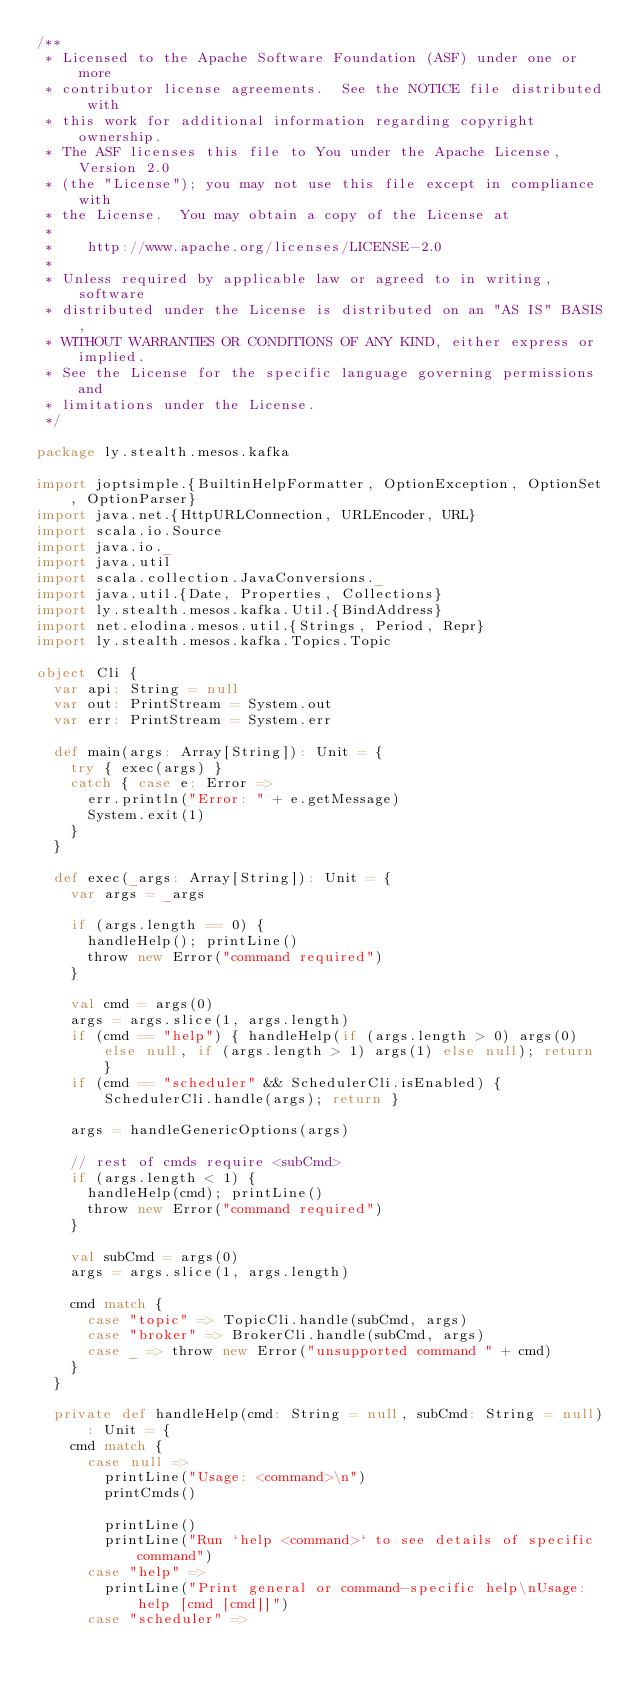<code> <loc_0><loc_0><loc_500><loc_500><_Scala_>/**
 * Licensed to the Apache Software Foundation (ASF) under one or more
 * contributor license agreements.  See the NOTICE file distributed with
 * this work for additional information regarding copyright ownership.
 * The ASF licenses this file to You under the Apache License, Version 2.0
 * (the "License"); you may not use this file except in compliance with
 * the License.  You may obtain a copy of the License at
 *
 *    http://www.apache.org/licenses/LICENSE-2.0
 *
 * Unless required by applicable law or agreed to in writing, software
 * distributed under the License is distributed on an "AS IS" BASIS,
 * WITHOUT WARRANTIES OR CONDITIONS OF ANY KIND, either express or implied.
 * See the License for the specific language governing permissions and
 * limitations under the License.
 */

package ly.stealth.mesos.kafka

import joptsimple.{BuiltinHelpFormatter, OptionException, OptionSet, OptionParser}
import java.net.{HttpURLConnection, URLEncoder, URL}
import scala.io.Source
import java.io._
import java.util
import scala.collection.JavaConversions._
import java.util.{Date, Properties, Collections}
import ly.stealth.mesos.kafka.Util.{BindAddress}
import net.elodina.mesos.util.{Strings, Period, Repr}
import ly.stealth.mesos.kafka.Topics.Topic

object Cli {
  var api: String = null
  var out: PrintStream = System.out
  var err: PrintStream = System.err

  def main(args: Array[String]): Unit = {
    try { exec(args) }
    catch { case e: Error =>
      err.println("Error: " + e.getMessage)
      System.exit(1)
    }
  }
  
  def exec(_args: Array[String]): Unit = {
    var args = _args

    if (args.length == 0) {
      handleHelp(); printLine()
      throw new Error("command required")
    }

    val cmd = args(0)
    args = args.slice(1, args.length)
    if (cmd == "help") { handleHelp(if (args.length > 0) args(0) else null, if (args.length > 1) args(1) else null); return }
    if (cmd == "scheduler" && SchedulerCli.isEnabled) { SchedulerCli.handle(args); return }

    args = handleGenericOptions(args)

    // rest of cmds require <subCmd>
    if (args.length < 1) {
      handleHelp(cmd); printLine()
      throw new Error("command required")
    }

    val subCmd = args(0)
    args = args.slice(1, args.length)

    cmd match {
      case "topic" => TopicCli.handle(subCmd, args)
      case "broker" => BrokerCli.handle(subCmd, args)
      case _ => throw new Error("unsupported command " + cmd)
    }
  }

  private def handleHelp(cmd: String = null, subCmd: String = null): Unit = {
    cmd match {
      case null =>
        printLine("Usage: <command>\n")
        printCmds()

        printLine()
        printLine("Run `help <command>` to see details of specific command")
      case "help" =>
        printLine("Print general or command-specific help\nUsage: help [cmd [cmd]]")
      case "scheduler" =></code> 